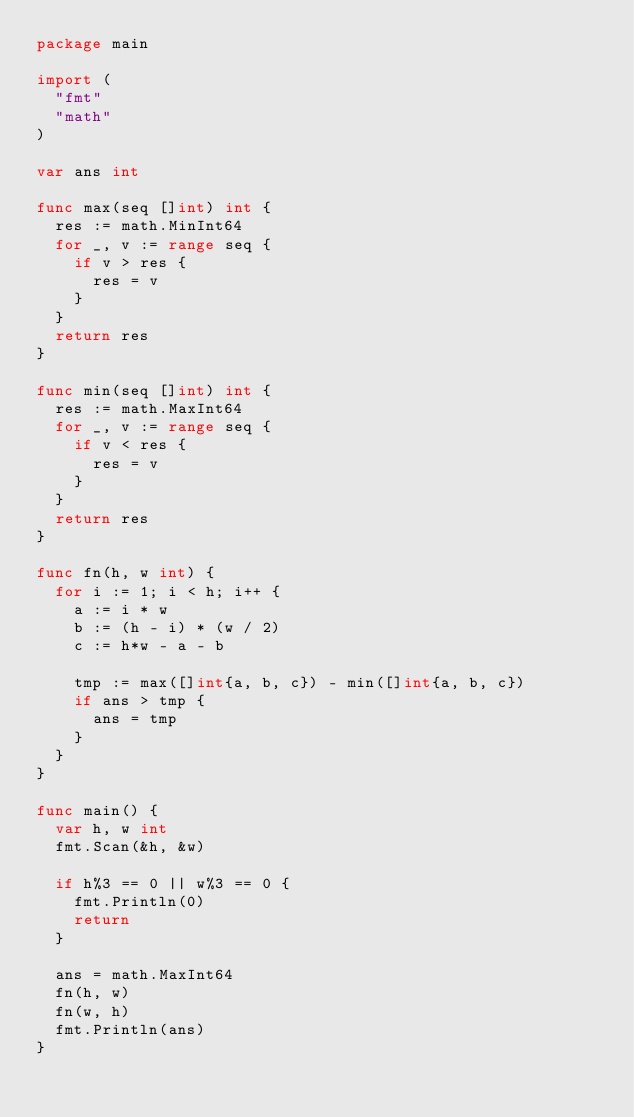Convert code to text. <code><loc_0><loc_0><loc_500><loc_500><_Go_>package main

import (
	"fmt"
	"math"
)

var ans int

func max(seq []int) int {
	res := math.MinInt64
	for _, v := range seq {
		if v > res {
			res = v
		}
	}
	return res
}

func min(seq []int) int {
	res := math.MaxInt64
	for _, v := range seq {
		if v < res {
			res = v
		}
	}
	return res
}

func fn(h, w int) {
	for i := 1; i < h; i++ {
		a := i * w
		b := (h - i) * (w / 2)
		c := h*w - a - b

		tmp := max([]int{a, b, c}) - min([]int{a, b, c})
		if ans > tmp {
			ans = tmp
		}
	}
}

func main() {
	var h, w int
	fmt.Scan(&h, &w)

	if h%3 == 0 || w%3 == 0 {
		fmt.Println(0)
		return
	}

	ans = math.MaxInt64
	fn(h, w)
	fn(w, h)
	fmt.Println(ans)
}
</code> 